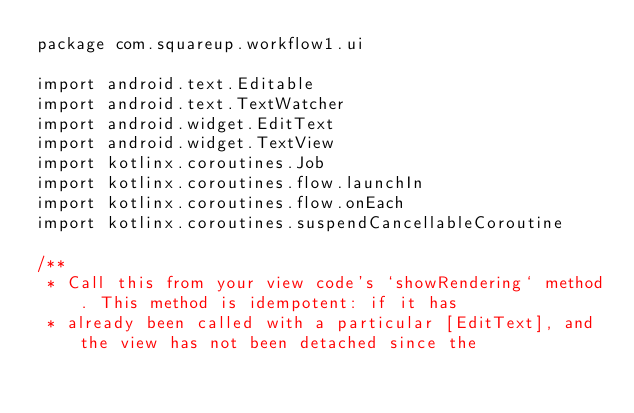<code> <loc_0><loc_0><loc_500><loc_500><_Kotlin_>package com.squareup.workflow1.ui

import android.text.Editable
import android.text.TextWatcher
import android.widget.EditText
import android.widget.TextView
import kotlinx.coroutines.Job
import kotlinx.coroutines.flow.launchIn
import kotlinx.coroutines.flow.onEach
import kotlinx.coroutines.suspendCancellableCoroutine

/**
 * Call this from your view code's `showRendering` method. This method is idempotent: if it has
 * already been called with a particular [EditText], and the view has not been detached since the</code> 